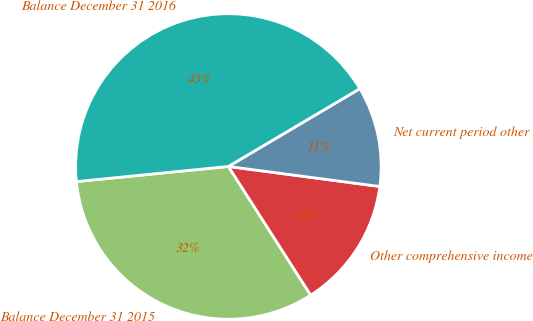Convert chart. <chart><loc_0><loc_0><loc_500><loc_500><pie_chart><fcel>Balance December 31 2015<fcel>Other comprehensive income<fcel>Net current period other<fcel>Balance December 31 2016<nl><fcel>32.48%<fcel>13.85%<fcel>10.6%<fcel>43.08%<nl></chart> 